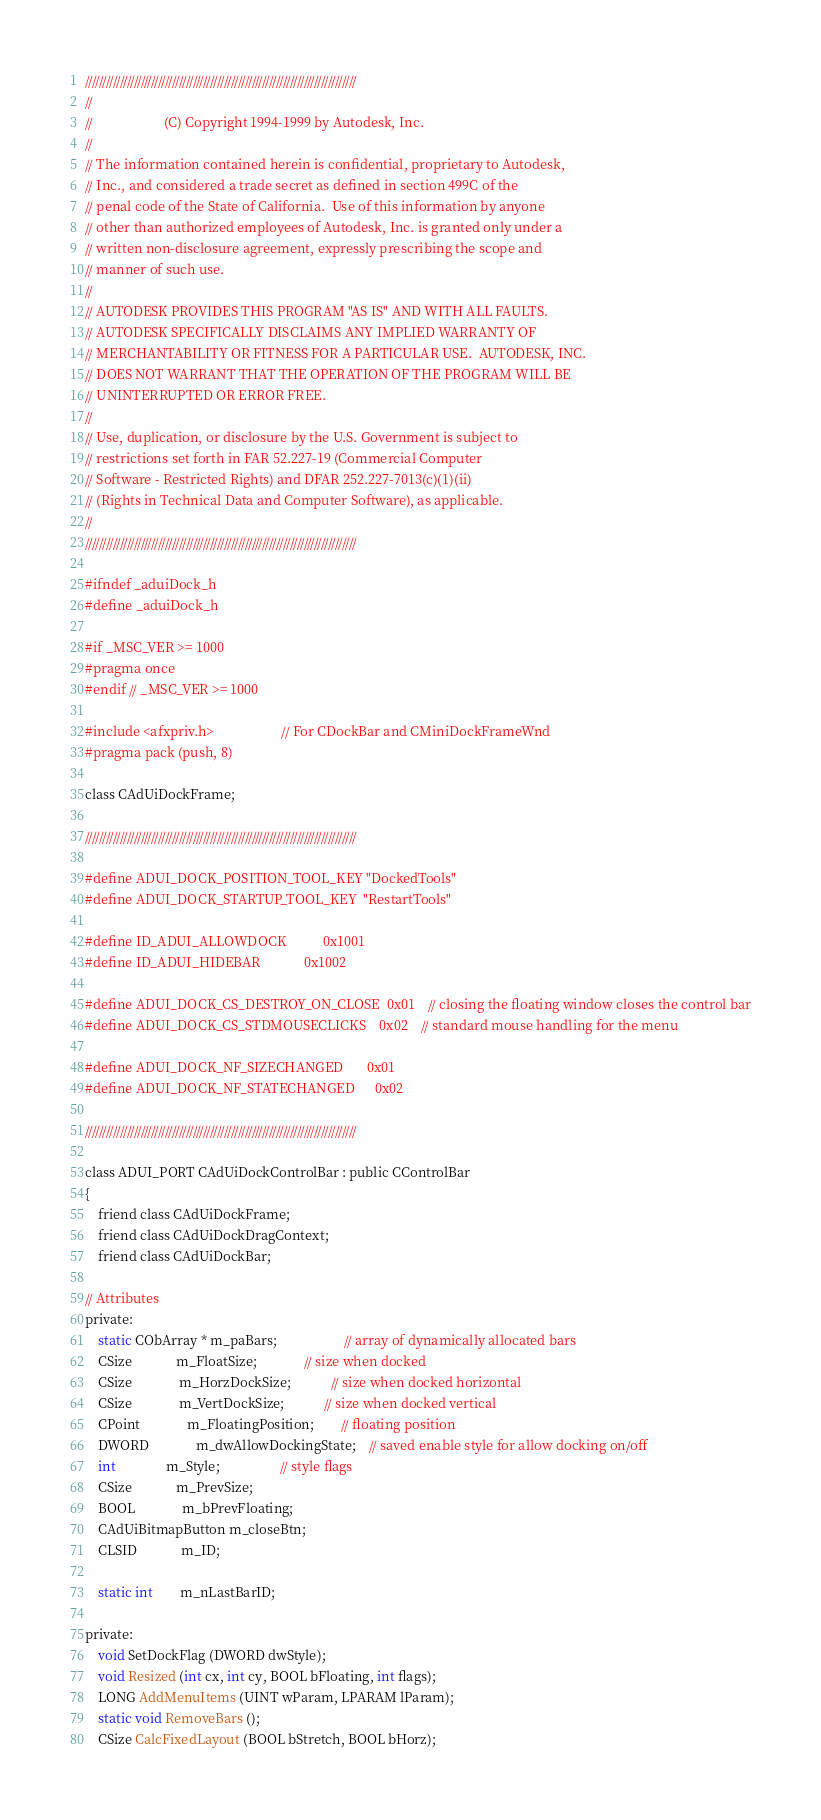<code> <loc_0><loc_0><loc_500><loc_500><_C_>//////////////////////////////////////////////////////////////////////////////
//
//                     (C) Copyright 1994-1999 by Autodesk, Inc.
//
// The information contained herein is confidential, proprietary to Autodesk,
// Inc., and considered a trade secret as defined in section 499C of the
// penal code of the State of California.  Use of this information by anyone
// other than authorized employees of Autodesk, Inc. is granted only under a
// written non-disclosure agreement, expressly prescribing the scope and
// manner of such use.
//
// AUTODESK PROVIDES THIS PROGRAM "AS IS" AND WITH ALL FAULTS. 
// AUTODESK SPECIFICALLY DISCLAIMS ANY IMPLIED WARRANTY OF
// MERCHANTABILITY OR FITNESS FOR A PARTICULAR USE.  AUTODESK, INC. 
// DOES NOT WARRANT THAT THE OPERATION OF THE PROGRAM WILL BE
// UNINTERRUPTED OR ERROR FREE.
//
// Use, duplication, or disclosure by the U.S. Government is subject to 
// restrictions set forth in FAR 52.227-19 (Commercial Computer
// Software - Restricted Rights) and DFAR 252.227-7013(c)(1)(ii)
// (Rights in Technical Data and Computer Software), as applicable.
//
//////////////////////////////////////////////////////////////////////////////

#ifndef _aduiDock_h
#define _aduiDock_h

#if _MSC_VER >= 1000
#pragma once
#endif // _MSC_VER >= 1000

#include <afxpriv.h>                    // For CDockBar and CMiniDockFrameWnd
#pragma pack (push, 8)

class CAdUiDockFrame;

//////////////////////////////////////////////////////////////////////////////

#define ADUI_DOCK_POSITION_TOOL_KEY "DockedTools"
#define ADUI_DOCK_STARTUP_TOOL_KEY  "RestartTools"

#define ID_ADUI_ALLOWDOCK           0x1001
#define ID_ADUI_HIDEBAR             0x1002

#define ADUI_DOCK_CS_DESTROY_ON_CLOSE  0x01    // closing the floating window closes the control bar
#define ADUI_DOCK_CS_STDMOUSECLICKS    0x02    // standard mouse handling for the menu

#define ADUI_DOCK_NF_SIZECHANGED       0x01
#define ADUI_DOCK_NF_STATECHANGED      0x02

//////////////////////////////////////////////////////////////////////////////

class ADUI_PORT CAdUiDockControlBar : public CControlBar
{
    friend class CAdUiDockFrame;
    friend class CAdUiDockDragContext;
    friend class CAdUiDockBar;

// Attributes
private:
	static CObArray * m_paBars;				    // array of dynamically allocated bars
	CSize             m_FloatSize;              // size when docked
   	CSize			  m_HorzDockSize;			// size when docked horizontal
	CSize			  m_VertDockSize;			// size when docked vertical
    CPoint			  m_FloatingPosition;		// floating position
	DWORD			  m_dwAllowDockingState;    // saved enable style for allow docking on/off
    int               m_Style;                  // style flags
    CSize             m_PrevSize;
    BOOL              m_bPrevFloating;
	CAdUiBitmapButton m_closeBtn;
    CLSID             m_ID;

    static int        m_nLastBarID;

private:
	void SetDockFlag (DWORD dwStyle);
	void Resized (int cx, int cy, BOOL bFloating, int flags);
	LONG AddMenuItems (UINT wParam, LPARAM lParam);
	static void RemoveBars ();
    CSize CalcFixedLayout (BOOL bStretch, BOOL bHorz);</code> 